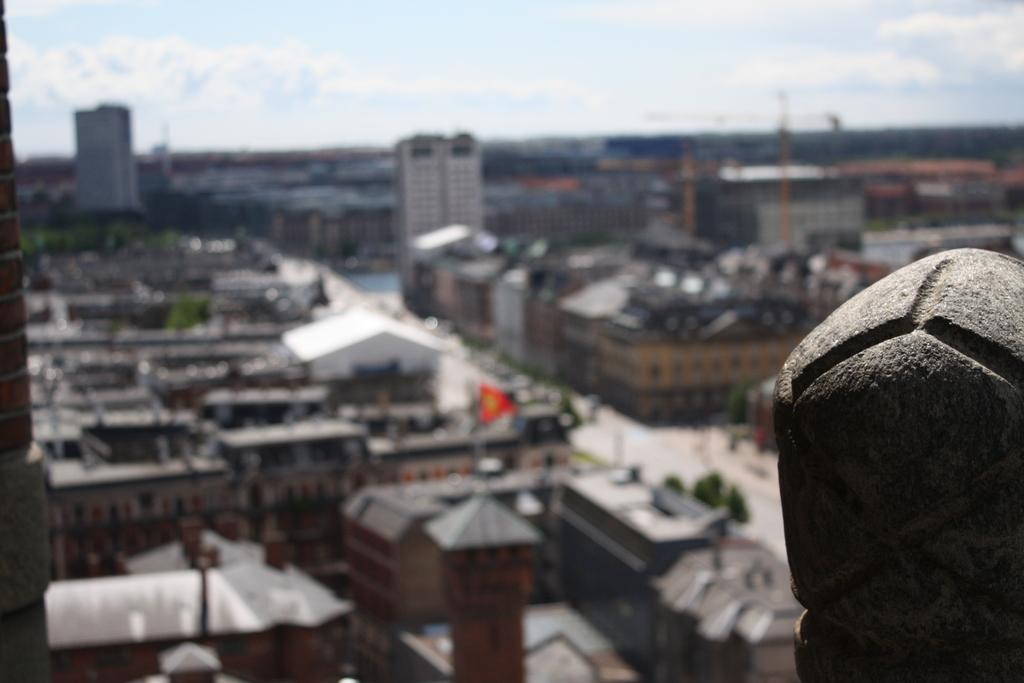What type of structures can be seen in the image? There are buildings in the image. What natural elements are present in the image? There are trees in the image. What can be seen in the sky in the image? There are clouds in the image. What part of the natural environment is visible in the image? The sky is visible in the image. Where is the owl sitting in the image? There is no owl present in the image. What type of market can be seen in the image? There is no market present in the image. 